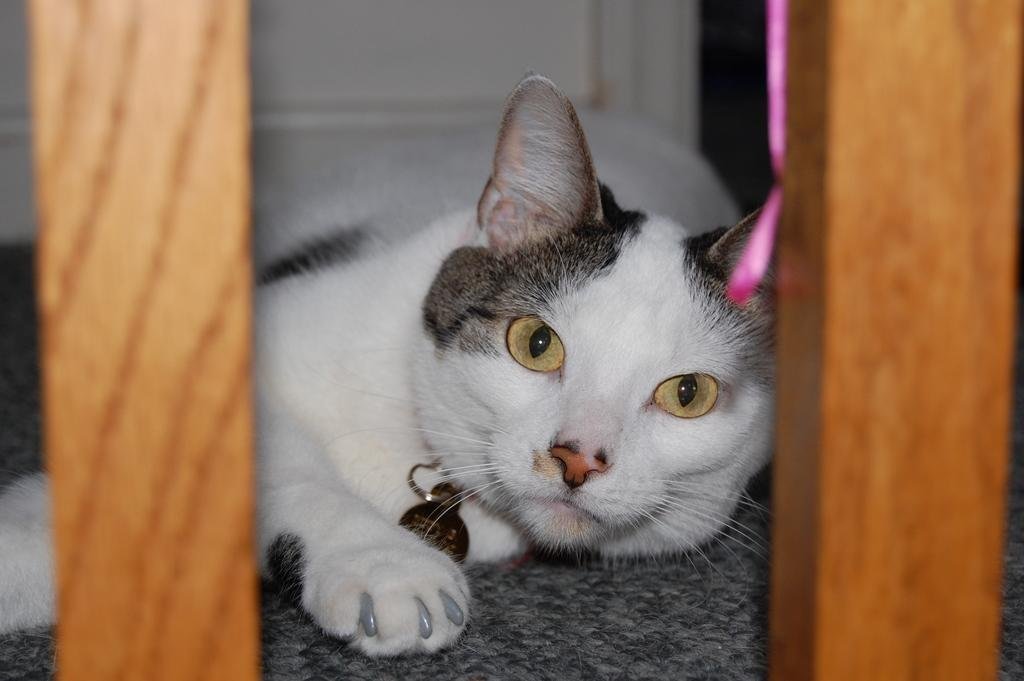What animal is present in the image? There is a cat in the image. What is the cat lying on? The cat is lying on a mat. What colors can be seen on the cat? The cat is white and black in color. What type of objects are on both sides of the image? There are wooden poles on both the left and right sides of the image. Can you see any oil spills on the seashore in the image? There is no seashore or oil spills present in the image; it features a cat lying on a mat with wooden poles on both sides. 